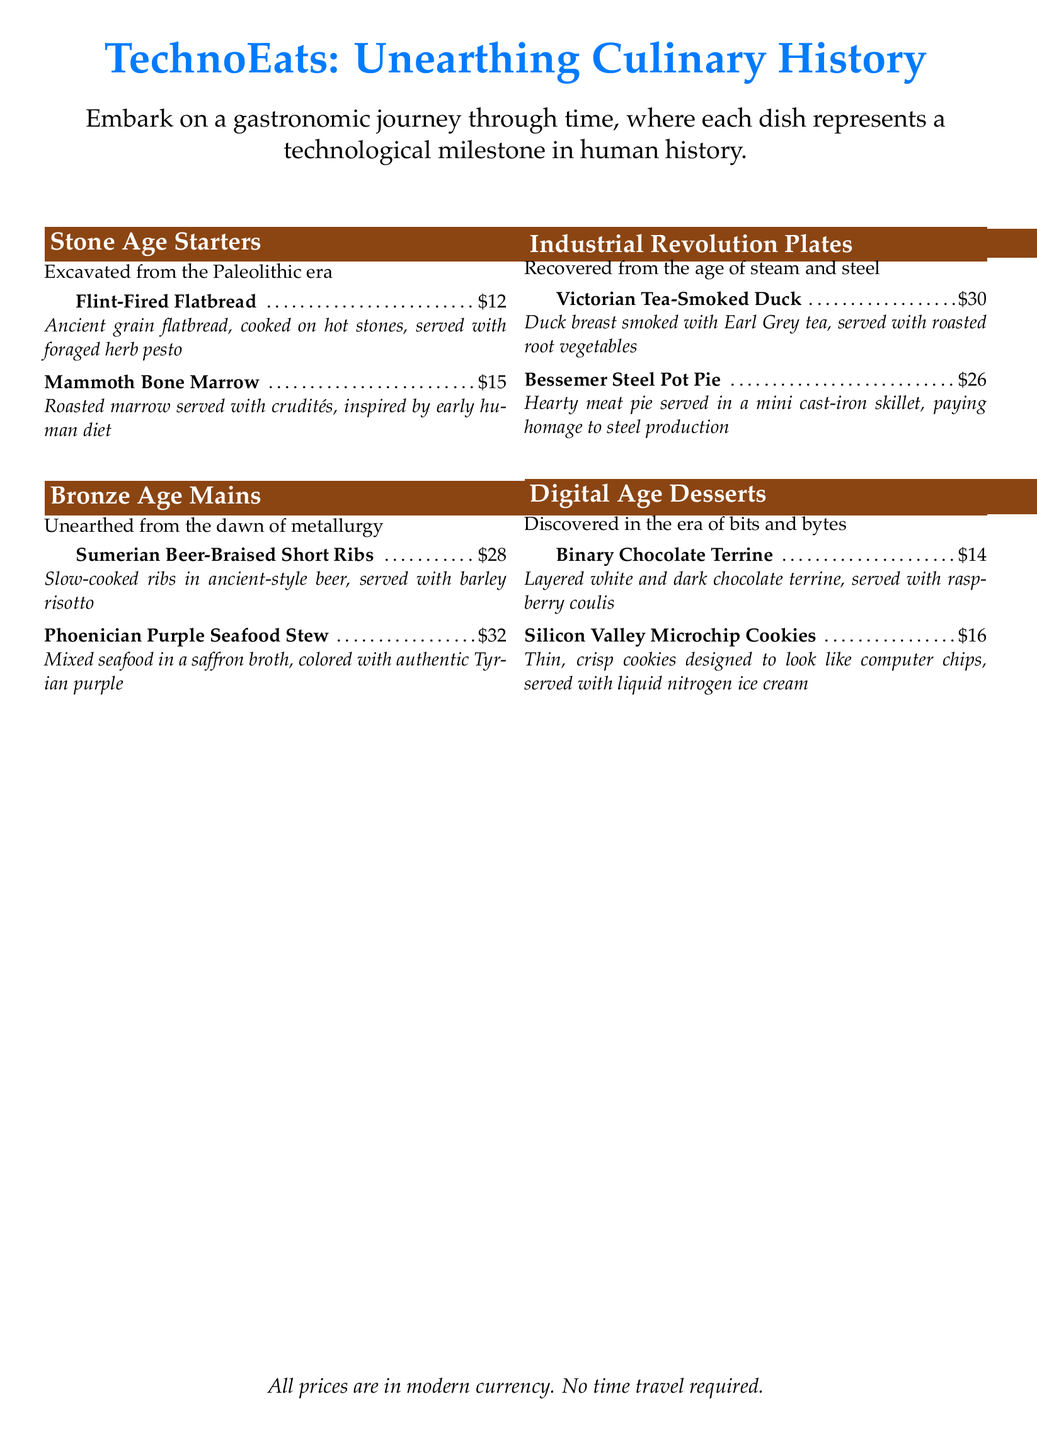What is the name of the dish from the Stone Age? The dishes from the Stone Age are listed under the 'Stone Age Starters' section.
Answer: Flint-Fired Flatbread How much does the Phoenician Purple Seafood Stew cost? The price is listed next to the dish name in the menu.
Answer: $32 What type of meat is used in the Bessemer Steel Pot Pie? The menu mentions "hearty meat pie," which indicates a meat-based dish.
Answer: Meat What era does the Binary Chocolate Terrine belong to? The dish is categorized under the 'Digital Age Desserts' section in the menu.
Answer: Digital Age How many Stone Age Starters are listed on the menu? The document provides a count of the menu items listed under the 'Stone Age Starters' section.
Answer: 2 Which dish is smoked with Earl Grey tea? The 'Industrial Revolution Plates' section specifies that it is the duck breast dish.
Answer: Victorian Tea-Smoked Duck What is the unique feature of the Silicon Valley Microchip Cookies? The menu describes their design as resembling computer chips, indicating a thematic presentation.
Answer: Computer chips How many main dishes are featured from the Bronze Age? The menu clearly indicates the count of main dishes listed under the 'Bronze Age Mains' section.
Answer: 2 